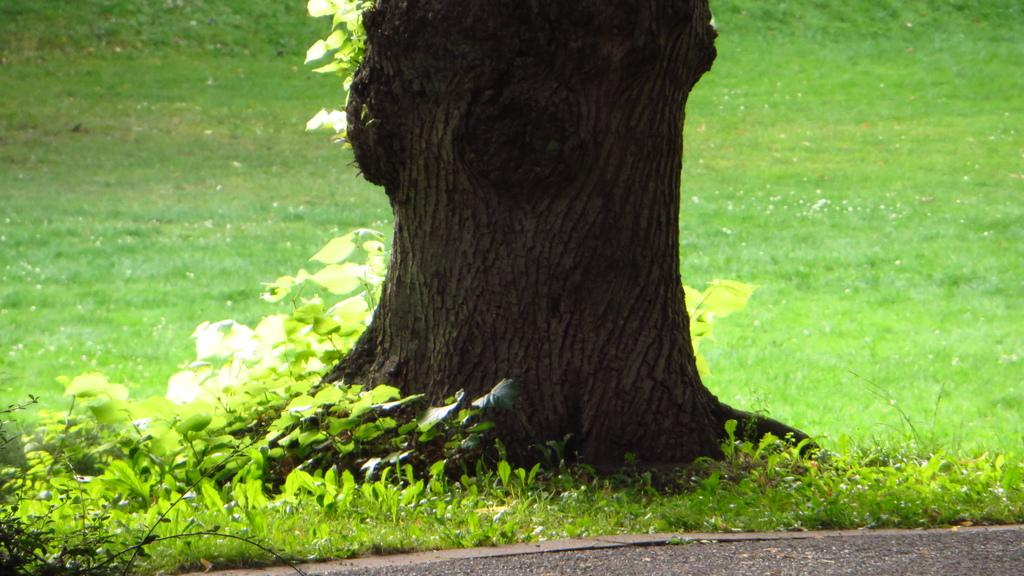What type of vegetation covers the land in the image? The land is covered with grass in the image. What other types of vegetation can be seen in the image? There are plants in the image. Can you describe a specific feature of the vegetation in the image? There is a tree trunk in the image. What type of love story is depicted in the image? There is no love story depicted in the image; it features grass-covered land, plants, and a tree trunk. Is the image based on a fictional plot? The image does not appear to be based on a fictional plot; it is a representation of natural vegetation. 